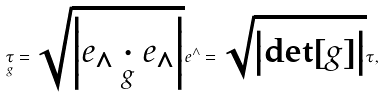Convert formula to latex. <formula><loc_0><loc_0><loc_500><loc_500>\underset { g } { \tau } = \sqrt { \left | e _ { \wedge } \underset { g } { \cdot } e _ { \wedge } \right | } e ^ { \wedge } = \sqrt { \left | \det [ g ] \right | } \tau ,</formula> 